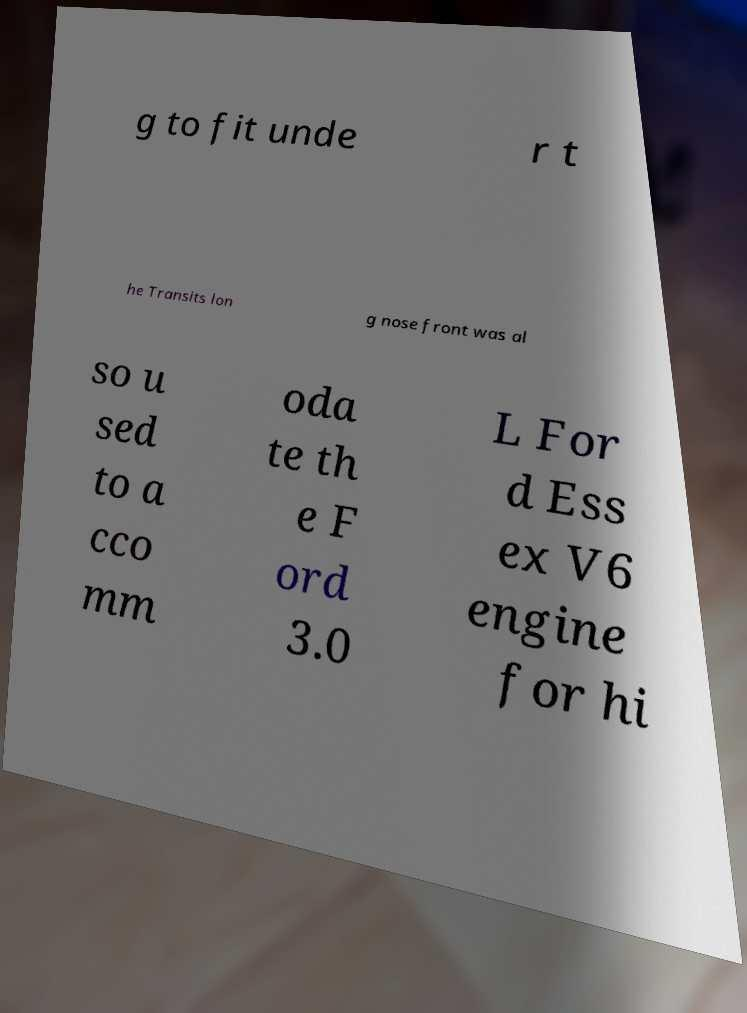Can you accurately transcribe the text from the provided image for me? g to fit unde r t he Transits lon g nose front was al so u sed to a cco mm oda te th e F ord 3.0 L For d Ess ex V6 engine for hi 